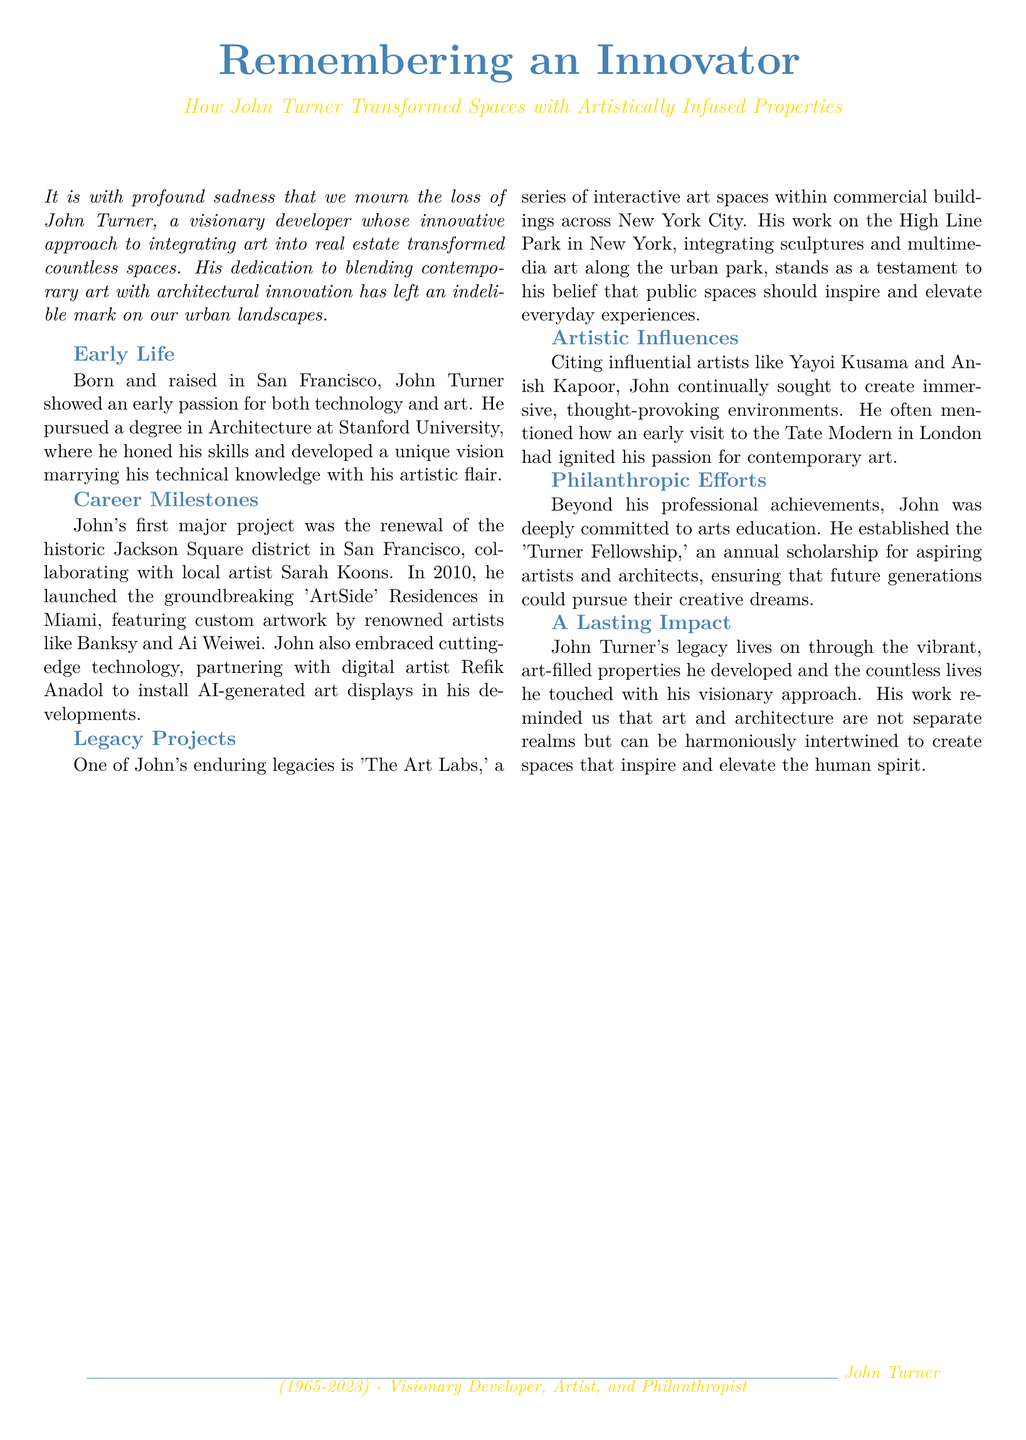What was John Turner's profession? John Turner was a visionary developer known for his innovative approach to integrating art into real estate.
Answer: Developer What year did John Turner pass away? The document states that John Turner died in 2023.
Answer: 2023 Which city was the 'ArtSide' Residences project located in? The document mentions that the 'ArtSide' Residences were launched in Miami.
Answer: Miami Who was John Turner's first major project collaborator? The document identifies local artist Sarah Koons as his collaborator for the Jackson Square district renewal.
Answer: Sarah Koons What scholarship did John Turner establish? The document describes the 'Turner Fellowship' as an annual scholarship for aspiring artists and architects.
Answer: Turner Fellowship What influential artist did John Turner cite as an influence? The document mentions Yayoi Kusama as one of the influential artists John Turner cited.
Answer: Yayoi Kusama What did John Turner believe about public spaces? The document states that he believed public spaces should inspire and elevate everyday experiences.
Answer: Inspire and elevate What is one of John Turner's legacy projects? The document lists 'The Art Labs' as one of his enduring legacy projects.
Answer: The Art Labs In what city did John develop interactive art spaces? The document indicates that the interactive art spaces were developed in New York City.
Answer: New York City 